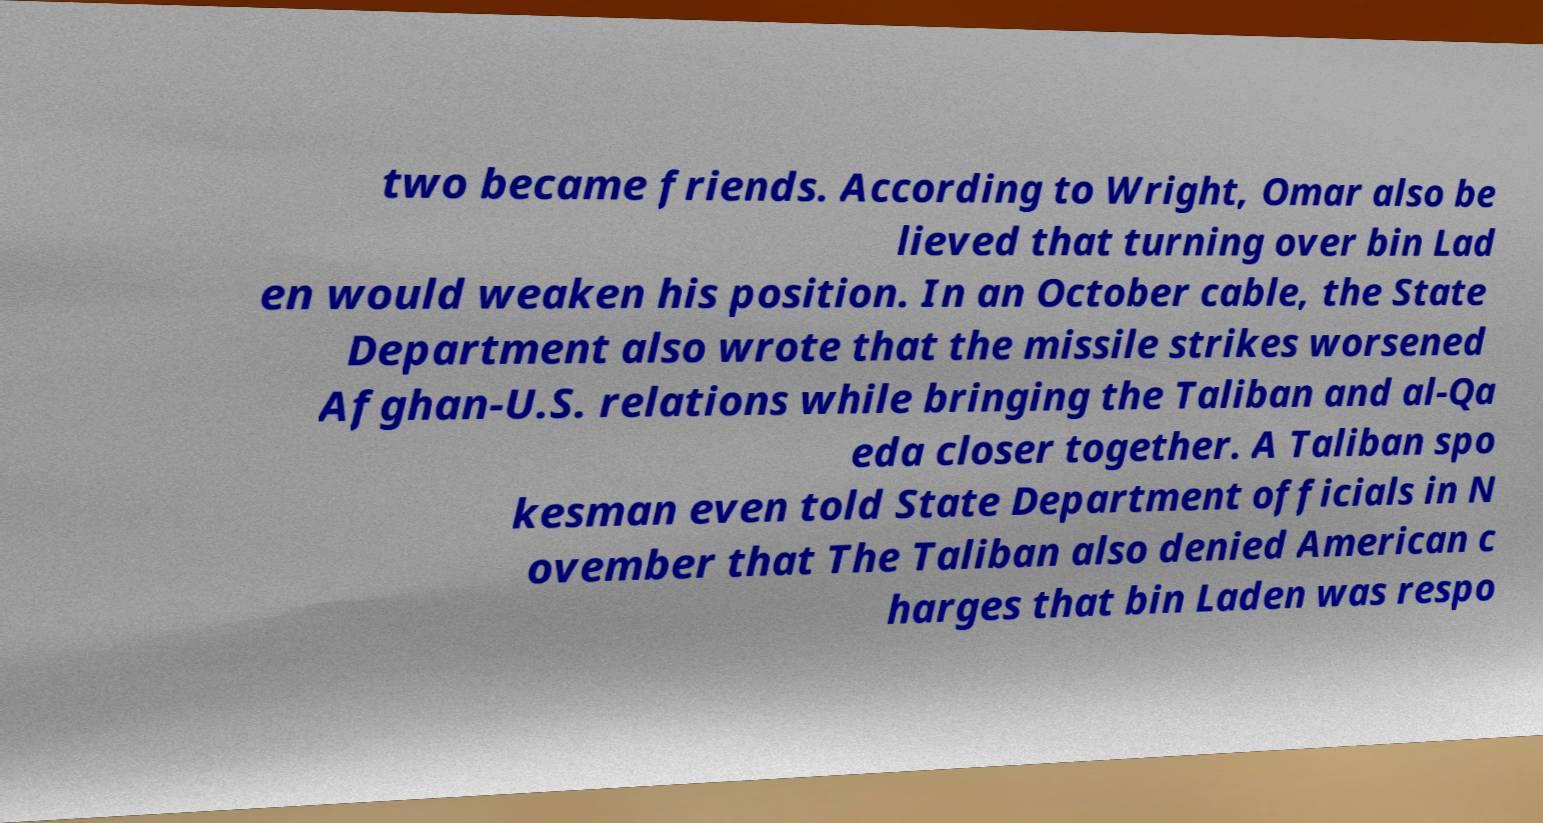Could you assist in decoding the text presented in this image and type it out clearly? two became friends. According to Wright, Omar also be lieved that turning over bin Lad en would weaken his position. In an October cable, the State Department also wrote that the missile strikes worsened Afghan-U.S. relations while bringing the Taliban and al-Qa eda closer together. A Taliban spo kesman even told State Department officials in N ovember that The Taliban also denied American c harges that bin Laden was respo 